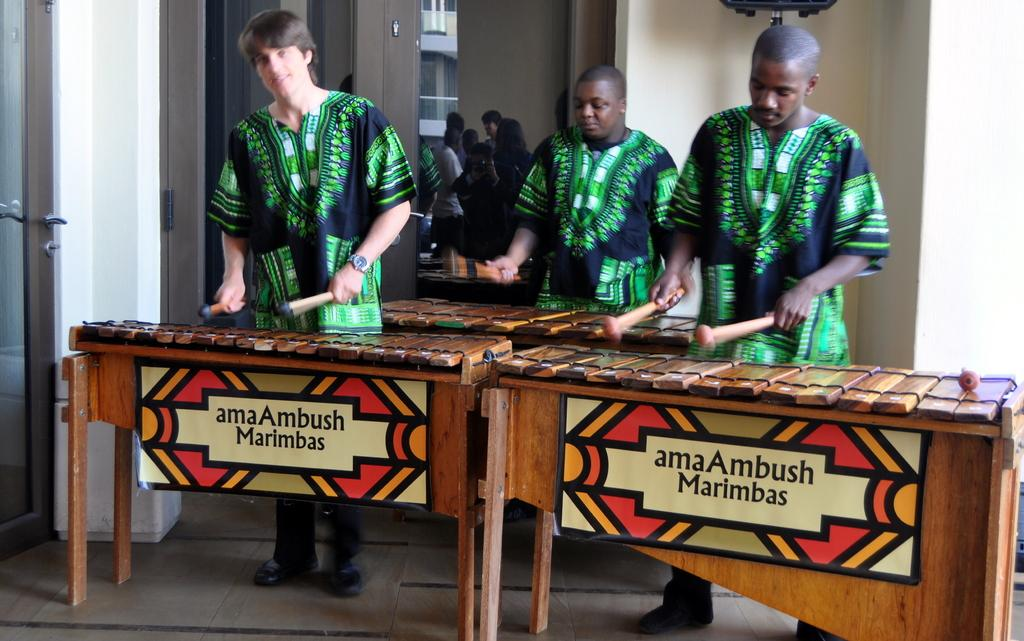How many people are in the image? There are three men in the image. What are the men doing in the image? The men are playing musical instruments. Can you describe the setting in which the men are playing their instruments? The men are in front of a table. What type of twig can be seen in the hands of the men in the image? There is no twig present in the image; the men are playing musical instruments. What year is depicted in the image? The image does not depict a specific year; it is a photograph of three men playing musical instruments. 